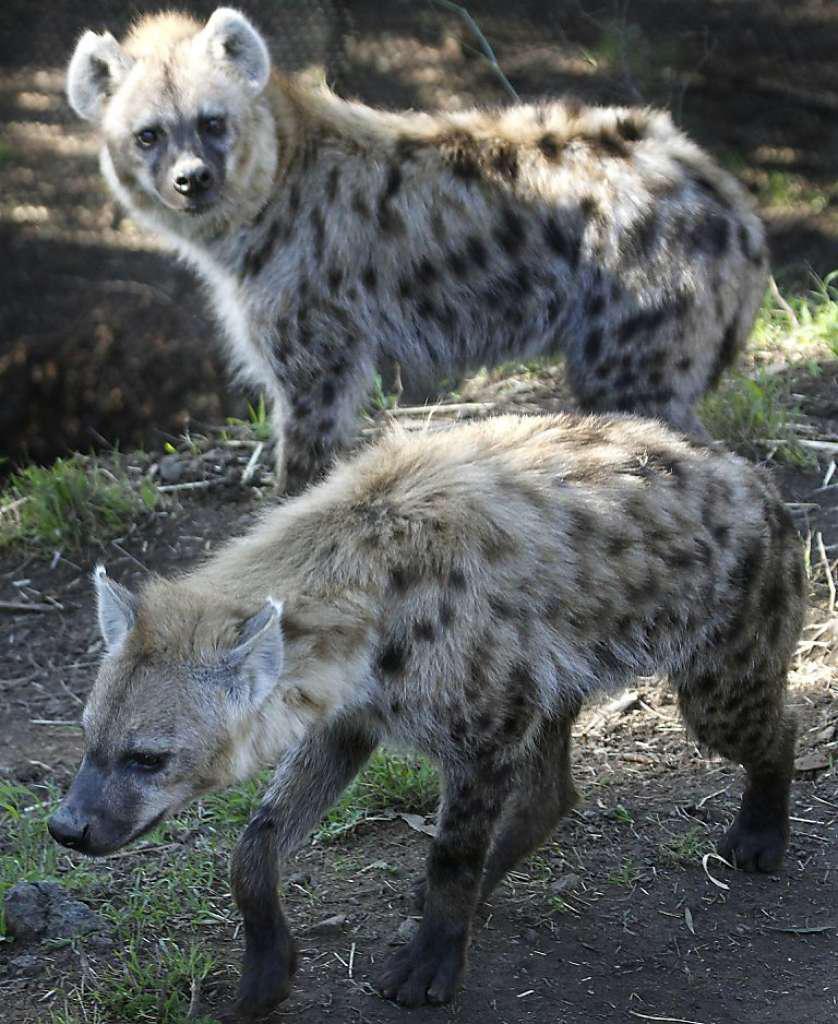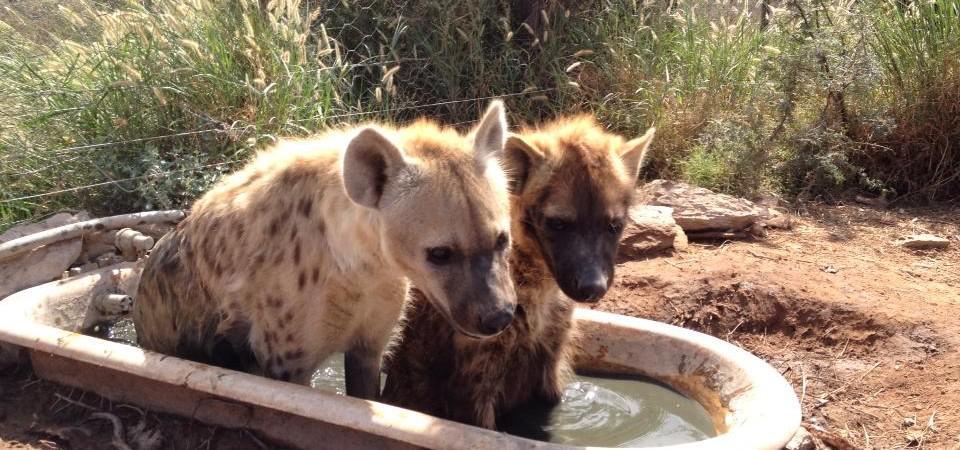The first image is the image on the left, the second image is the image on the right. Considering the images on both sides, is "At least one hyena has its legs in water." valid? Answer yes or no. Yes. The first image is the image on the left, the second image is the image on the right. Assess this claim about the two images: "A hyena is carrying something in its mouth.". Correct or not? Answer yes or no. No. 